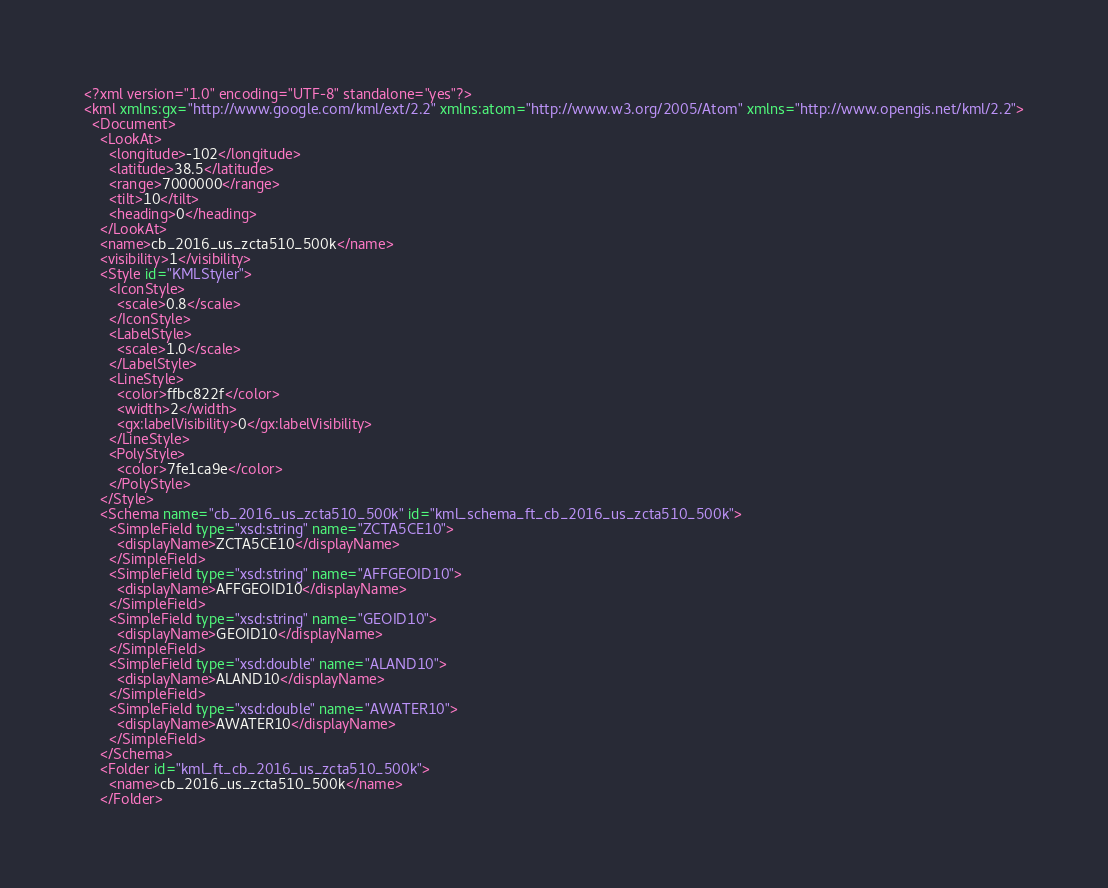Convert code to text. <code><loc_0><loc_0><loc_500><loc_500><_XML_><?xml version="1.0" encoding="UTF-8" standalone="yes"?>
<kml xmlns:gx="http://www.google.com/kml/ext/2.2" xmlns:atom="http://www.w3.org/2005/Atom" xmlns="http://www.opengis.net/kml/2.2">
  <Document>
    <LookAt>
      <longitude>-102</longitude>
      <latitude>38.5</latitude>
      <range>7000000</range>
      <tilt>10</tilt>
      <heading>0</heading>
    </LookAt>
    <name>cb_2016_us_zcta510_500k</name>
    <visibility>1</visibility>
    <Style id="KMLStyler">
      <IconStyle>
        <scale>0.8</scale>
      </IconStyle>
      <LabelStyle>
        <scale>1.0</scale>
      </LabelStyle>
      <LineStyle>
        <color>ffbc822f</color>
        <width>2</width>
        <gx:labelVisibility>0</gx:labelVisibility>
      </LineStyle>
      <PolyStyle>
        <color>7fe1ca9e</color>
      </PolyStyle>
    </Style>
    <Schema name="cb_2016_us_zcta510_500k" id="kml_schema_ft_cb_2016_us_zcta510_500k">
      <SimpleField type="xsd:string" name="ZCTA5CE10">
        <displayName>ZCTA5CE10</displayName>
      </SimpleField>
      <SimpleField type="xsd:string" name="AFFGEOID10">
        <displayName>AFFGEOID10</displayName>
      </SimpleField>
      <SimpleField type="xsd:string" name="GEOID10">
        <displayName>GEOID10</displayName>
      </SimpleField>
      <SimpleField type="xsd:double" name="ALAND10">
        <displayName>ALAND10</displayName>
      </SimpleField>
      <SimpleField type="xsd:double" name="AWATER10">
        <displayName>AWATER10</displayName>
      </SimpleField>
    </Schema>
    <Folder id="kml_ft_cb_2016_us_zcta510_500k">
      <name>cb_2016_us_zcta510_500k</name>
    </Folder></code> 